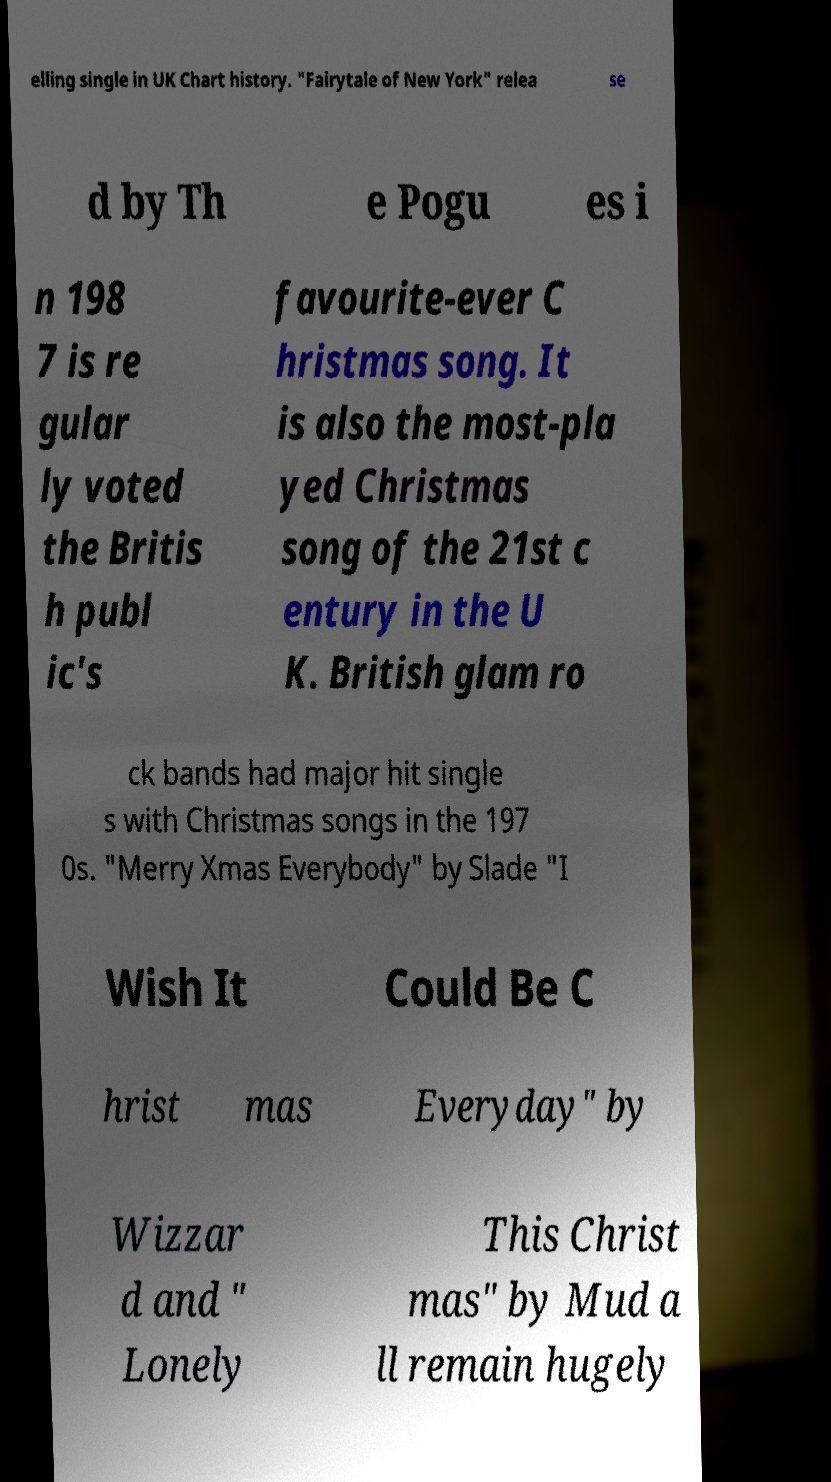For documentation purposes, I need the text within this image transcribed. Could you provide that? elling single in UK Chart history. "Fairytale of New York" relea se d by Th e Pogu es i n 198 7 is re gular ly voted the Britis h publ ic's favourite-ever C hristmas song. It is also the most-pla yed Christmas song of the 21st c entury in the U K. British glam ro ck bands had major hit single s with Christmas songs in the 197 0s. "Merry Xmas Everybody" by Slade "I Wish It Could Be C hrist mas Everyday" by Wizzar d and " Lonely This Christ mas" by Mud a ll remain hugely 